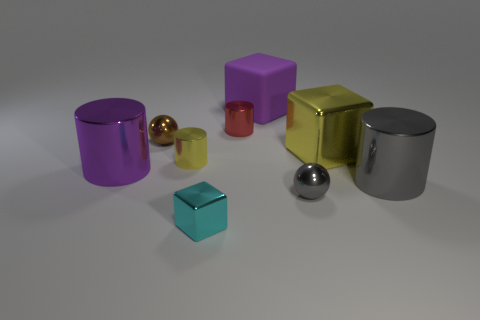Are there any other things that have the same material as the purple cube?
Provide a short and direct response. No. How many metal things have the same color as the matte thing?
Your answer should be compact. 1. How big is the metallic block that is behind the big metallic cylinder on the left side of the large gray thing?
Your response must be concise. Large. What is the shape of the large yellow metal thing?
Offer a very short reply. Cube. There is a big purple thing on the right side of the purple cylinder; what is its material?
Make the answer very short. Rubber. What color is the tiny shiny sphere on the right side of the small brown object that is behind the purple thing in front of the red shiny cylinder?
Keep it short and to the point. Gray. What is the color of the cube that is the same size as the red shiny cylinder?
Provide a short and direct response. Cyan. What number of shiny things are big purple things or tiny things?
Your response must be concise. 6. What is the color of the big cube that is made of the same material as the cyan thing?
Provide a short and direct response. Yellow. There is a ball behind the ball that is in front of the purple shiny object; what is it made of?
Provide a succinct answer. Metal. 